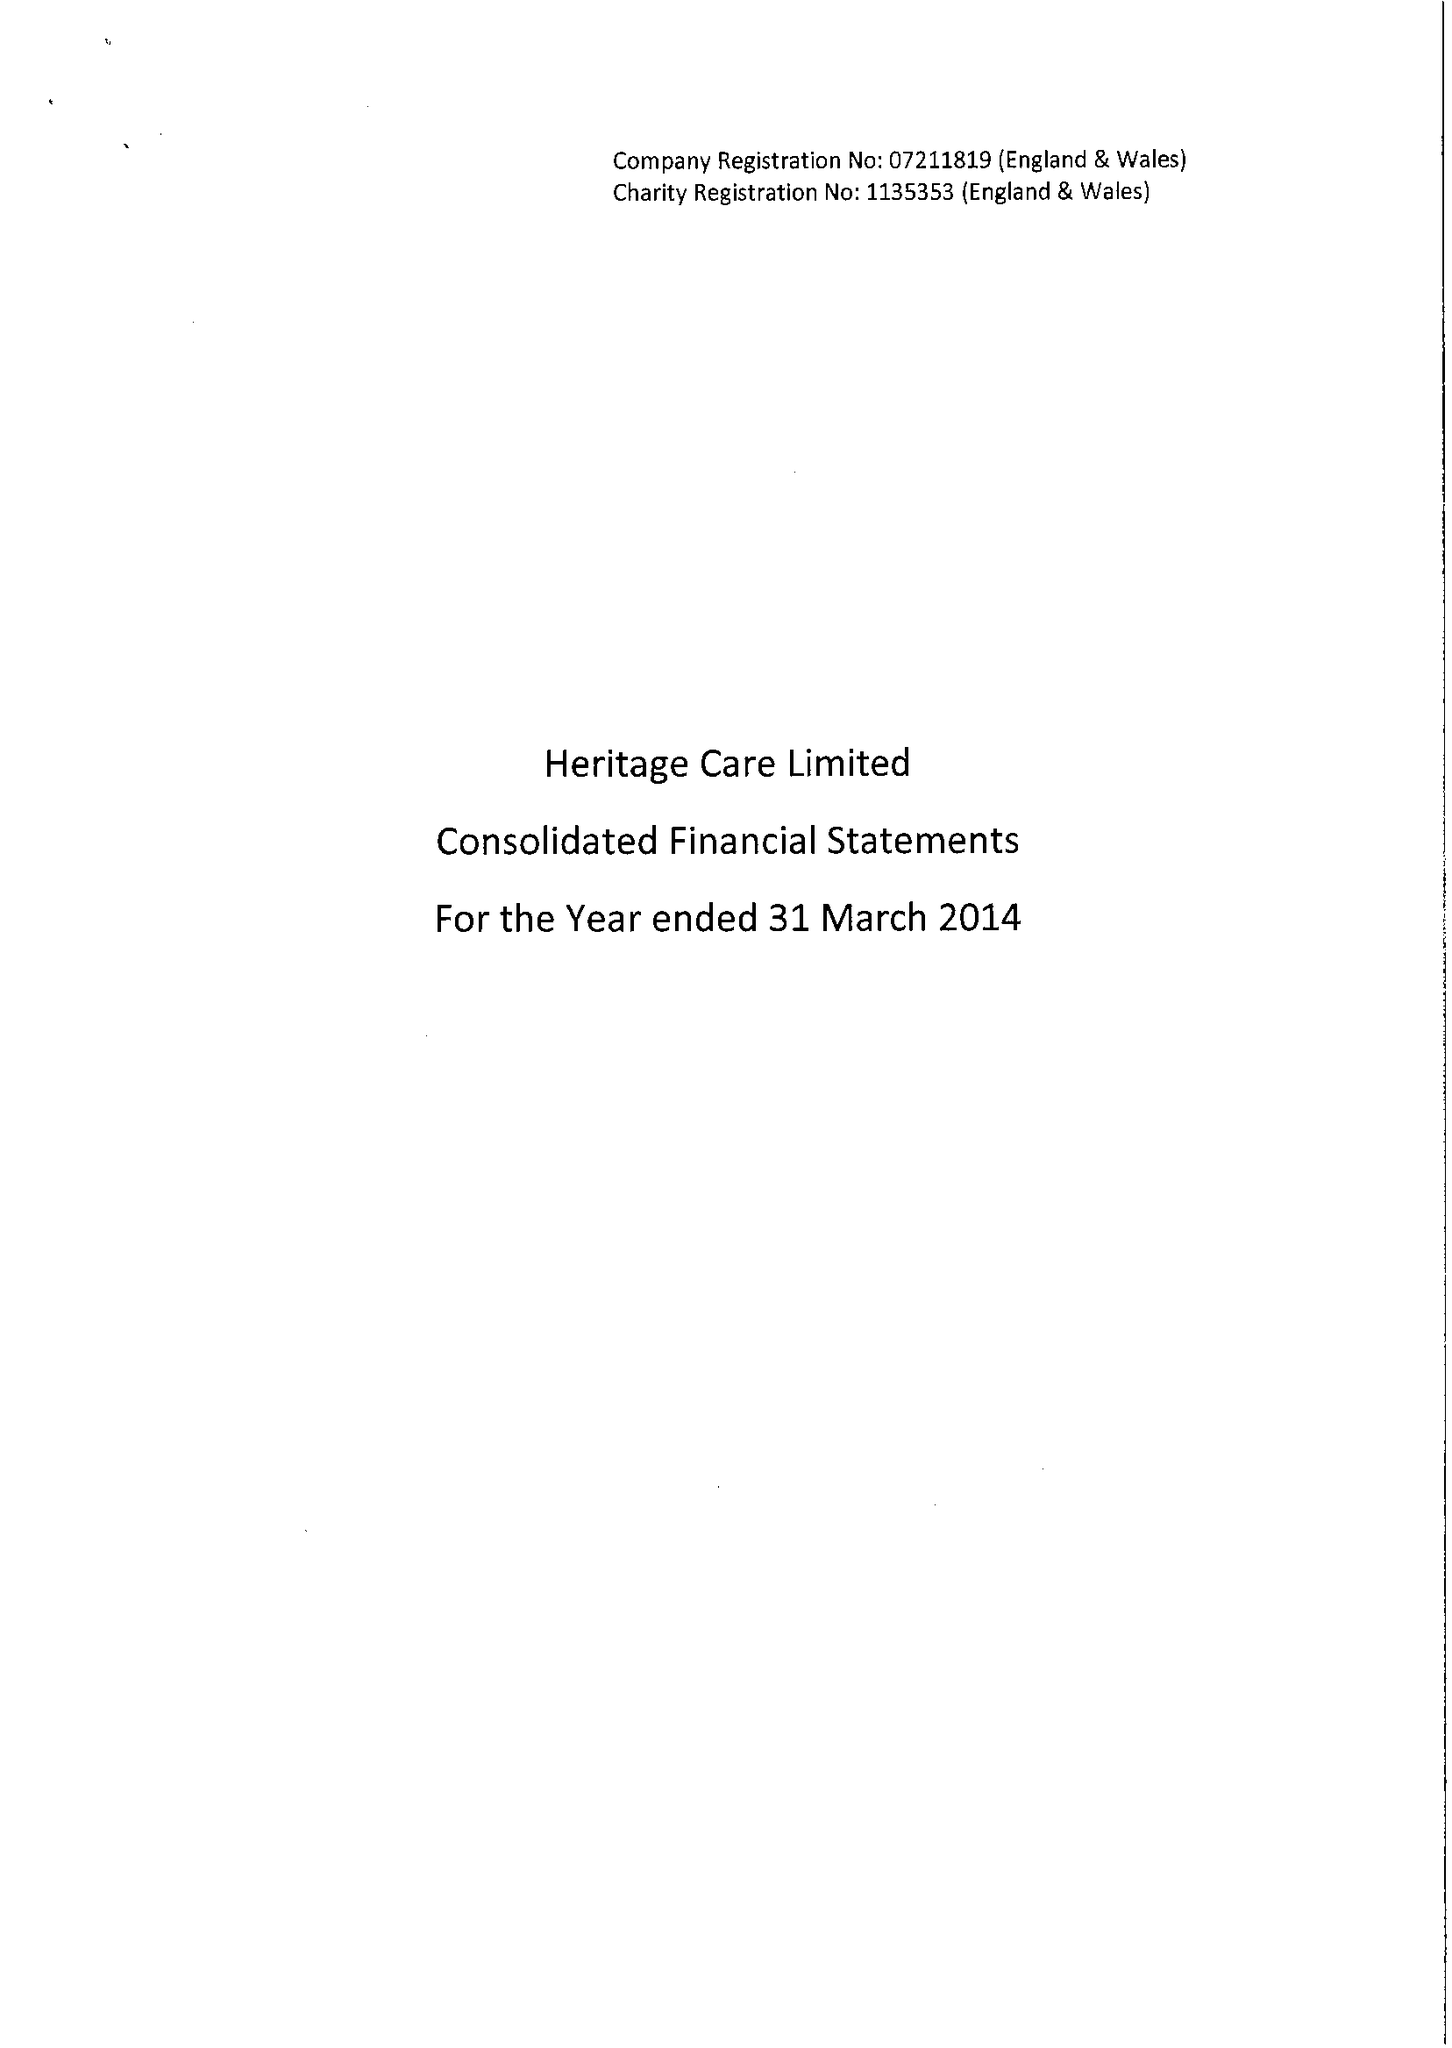What is the value for the address__postcode?
Answer the question using a single word or phrase. IG10 4HJ 